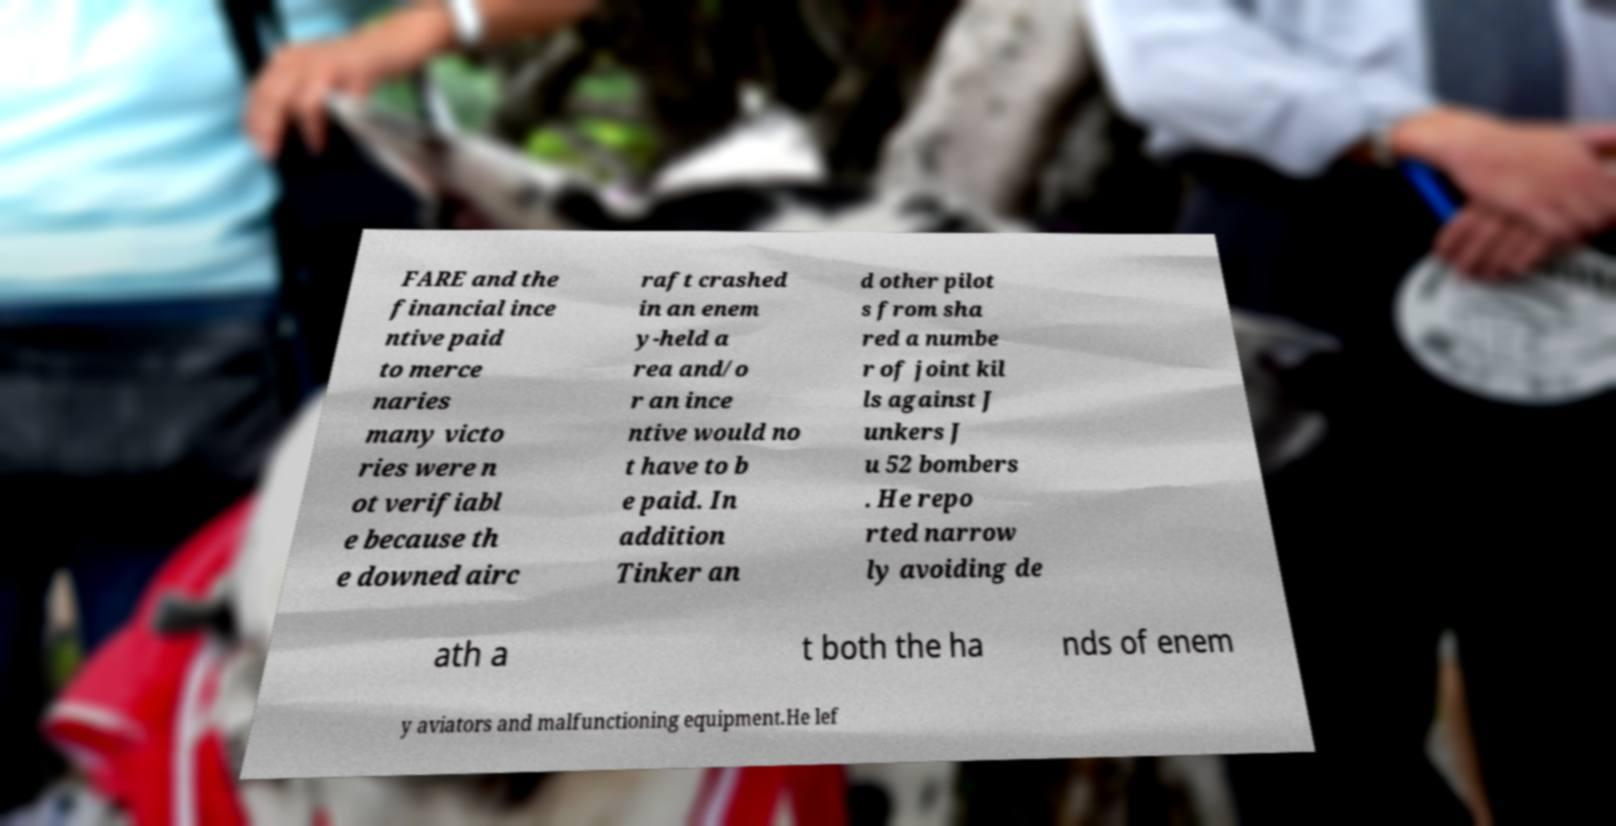I need the written content from this picture converted into text. Can you do that? FARE and the financial ince ntive paid to merce naries many victo ries were n ot verifiabl e because th e downed airc raft crashed in an enem y-held a rea and/o r an ince ntive would no t have to b e paid. In addition Tinker an d other pilot s from sha red a numbe r of joint kil ls against J unkers J u 52 bombers . He repo rted narrow ly avoiding de ath a t both the ha nds of enem y aviators and malfunctioning equipment.He lef 